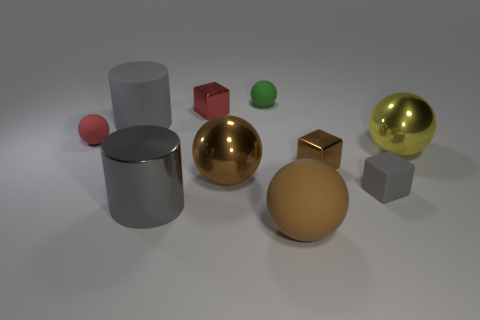What is the material of the tiny thing that is the same color as the metal cylinder?
Your answer should be compact. Rubber. What shape is the big metallic object that is both behind the large metallic cylinder and to the left of the large yellow thing?
Make the answer very short. Sphere. What number of objects are small rubber objects that are on the right side of the small red shiny block or large brown rubber spheres?
Your answer should be very brief. 3. What is the shape of the big matte object right of the metal cylinder?
Give a very brief answer. Sphere. Is the number of tiny green spheres behind the tiny green thing the same as the number of red matte things that are behind the large gray matte cylinder?
Provide a short and direct response. Yes. There is a small thing that is both left of the large matte ball and in front of the big gray matte object; what is its color?
Ensure brevity in your answer.  Red. What is the material of the tiny red thing that is to the left of the big cylinder behind the large yellow metal thing?
Your answer should be very brief. Rubber. Do the red metallic object and the brown rubber ball have the same size?
Make the answer very short. No. What number of tiny things are yellow shiny things or gray matte cylinders?
Offer a terse response. 0. There is a tiny matte block; what number of green matte balls are on the right side of it?
Make the answer very short. 0. 